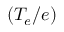<formula> <loc_0><loc_0><loc_500><loc_500>( T _ { e } / e )</formula> 